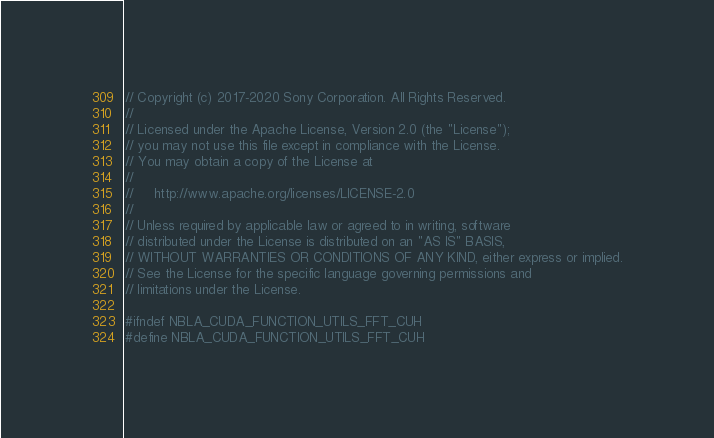Convert code to text. <code><loc_0><loc_0><loc_500><loc_500><_Cuda_>// Copyright (c) 2017-2020 Sony Corporation. All Rights Reserved.
//
// Licensed under the Apache License, Version 2.0 (the "License");
// you may not use this file except in compliance with the License.
// You may obtain a copy of the License at
//
//     http://www.apache.org/licenses/LICENSE-2.0
//
// Unless required by applicable law or agreed to in writing, software
// distributed under the License is distributed on an "AS IS" BASIS,
// WITHOUT WARRANTIES OR CONDITIONS OF ANY KIND, either express or implied.
// See the License for the specific language governing permissions and
// limitations under the License.

#ifndef NBLA_CUDA_FUNCTION_UTILS_FFT_CUH
#define NBLA_CUDA_FUNCTION_UTILS_FFT_CUH</code> 